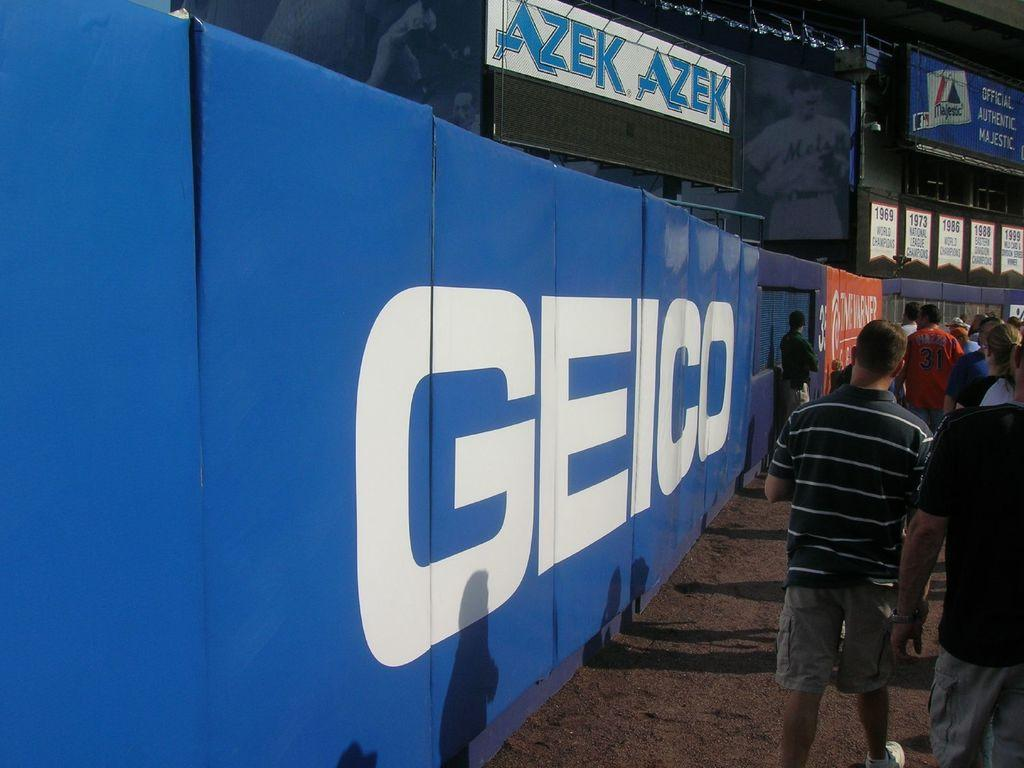What can be seen in the image involving people? There are people standing in the image. What else is visible in the image besides the people? Shadows and boards are visible in the image. What is written on the boards? Text is written on the boards. What type of cream is being spread on the marble surface in the image? There is no cream or marble surface present in the image. 